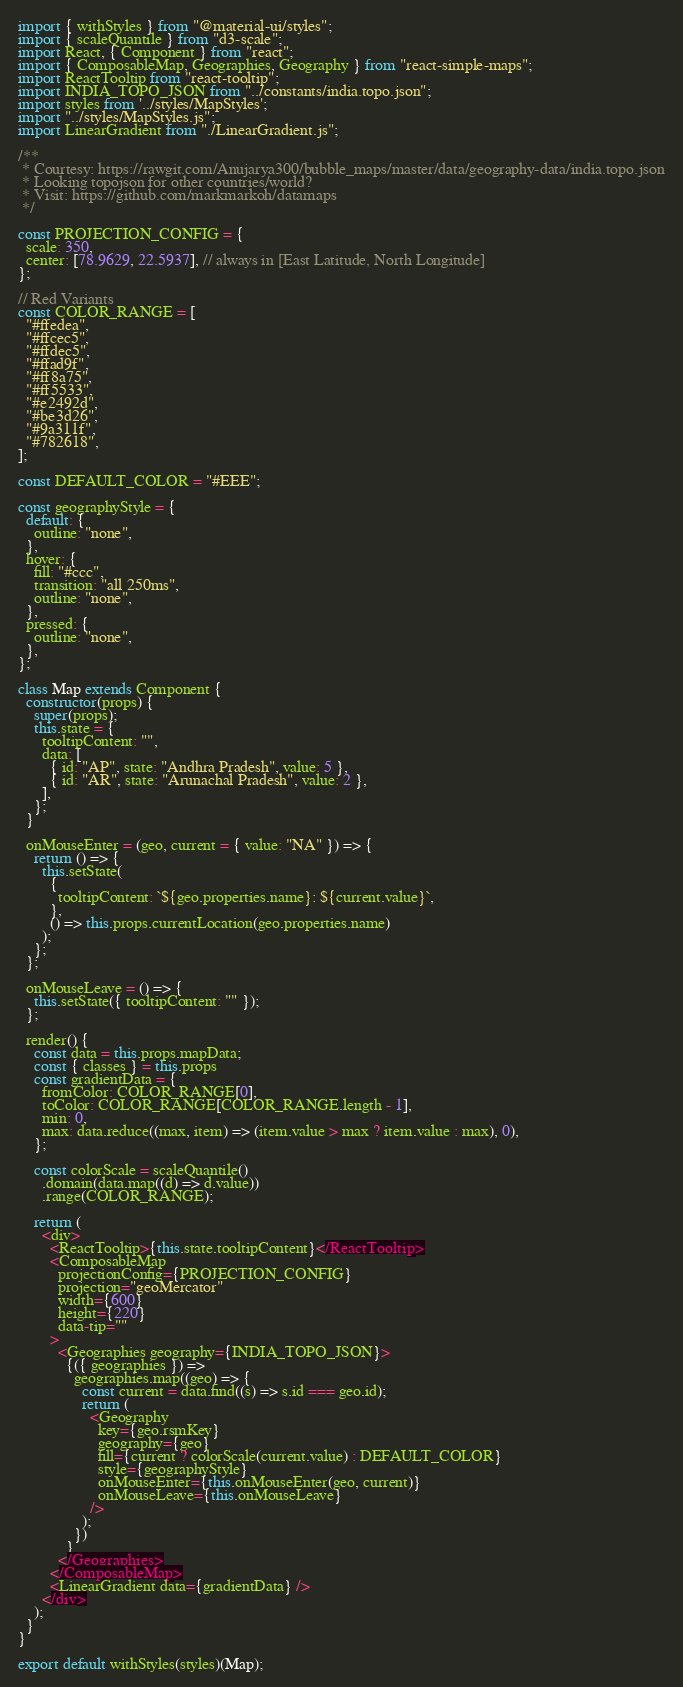<code> <loc_0><loc_0><loc_500><loc_500><_JavaScript_>import { withStyles } from "@material-ui/styles";
import { scaleQuantile } from "d3-scale";
import React, { Component } from "react";
import { ComposableMap, Geographies, Geography } from "react-simple-maps";
import ReactTooltip from "react-tooltip";
import INDIA_TOPO_JSON from "../constants/india.topo.json";
import styles from '../styles/MapStyles';
import "../styles/MapStyles.js";
import LinearGradient from "./LinearGradient.js";

/**
 * Courtesy: https://rawgit.com/Anujarya300/bubble_maps/master/data/geography-data/india.topo.json
 * Looking topojson for other countries/world?
 * Visit: https://github.com/markmarkoh/datamaps
 */

const PROJECTION_CONFIG = {
  scale: 350,
  center: [78.9629, 22.5937], // always in [East Latitude, North Longitude]
};

// Red Variants
const COLOR_RANGE = [
  "#ffedea",
  "#ffcec5",
  "#ffdec5",
  "#ffad9f",
  "#ff8a75",
  "#ff5533",
  "#e2492d",
  "#be3d26",
  "#9a311f",
  "#782618",
];

const DEFAULT_COLOR = "#EEE";

const geographyStyle = {
  default: {
    outline: "none",
  },
  hover: {
    fill: "#ccc",
    transition: "all 250ms",
    outline: "none",
  },
  pressed: {
    outline: "none",
  },
};

class Map extends Component {
  constructor(props) {
    super(props);
    this.state = {
      tooltipContent: "",
      data: [
        { id: "AP", state: "Andhra Pradesh", value: 5 },
        { id: "AR", state: "Arunachal Pradesh", value: 2 },
      ],
    };
  }

  onMouseEnter = (geo, current = { value: "NA" }) => {
    return () => {
      this.setState(
        {
          tooltipContent: `${geo.properties.name}: ${current.value}`,
        },
        () => this.props.currentLocation(geo.properties.name)
      );
    };
  };

  onMouseLeave = () => {
    this.setState({ tooltipContent: "" });
  };

  render() {
    const data = this.props.mapData;
    const { classes } = this.props
    const gradientData = {
      fromColor: COLOR_RANGE[0],
      toColor: COLOR_RANGE[COLOR_RANGE.length - 1],
      min: 0,
      max: data.reduce((max, item) => (item.value > max ? item.value : max), 0),
    };

    const colorScale = scaleQuantile()
      .domain(data.map((d) => d.value))
      .range(COLOR_RANGE);

    return (
      <div>
        <ReactTooltip>{this.state.tooltipContent}</ReactTooltip>
        <ComposableMap
          projectionConfig={PROJECTION_CONFIG}
          projection="geoMercator"
          width={600}
          height={220}
          data-tip=""
        >
          <Geographies geography={INDIA_TOPO_JSON}>
            {({ geographies }) =>
              geographies.map((geo) => {
                const current = data.find((s) => s.id === geo.id);
                return (
                  <Geography
                    key={geo.rsmKey}
                    geography={geo}
                    fill={current ? colorScale(current.value) : DEFAULT_COLOR}
                    style={geographyStyle}
                    onMouseEnter={this.onMouseEnter(geo, current)}
                    onMouseLeave={this.onMouseLeave}
                  />
                );
              })
            }
          </Geographies>
        </ComposableMap>
        <LinearGradient data={gradientData} />
      </div>
    );
  }
}

export default withStyles(styles)(Map);
</code> 